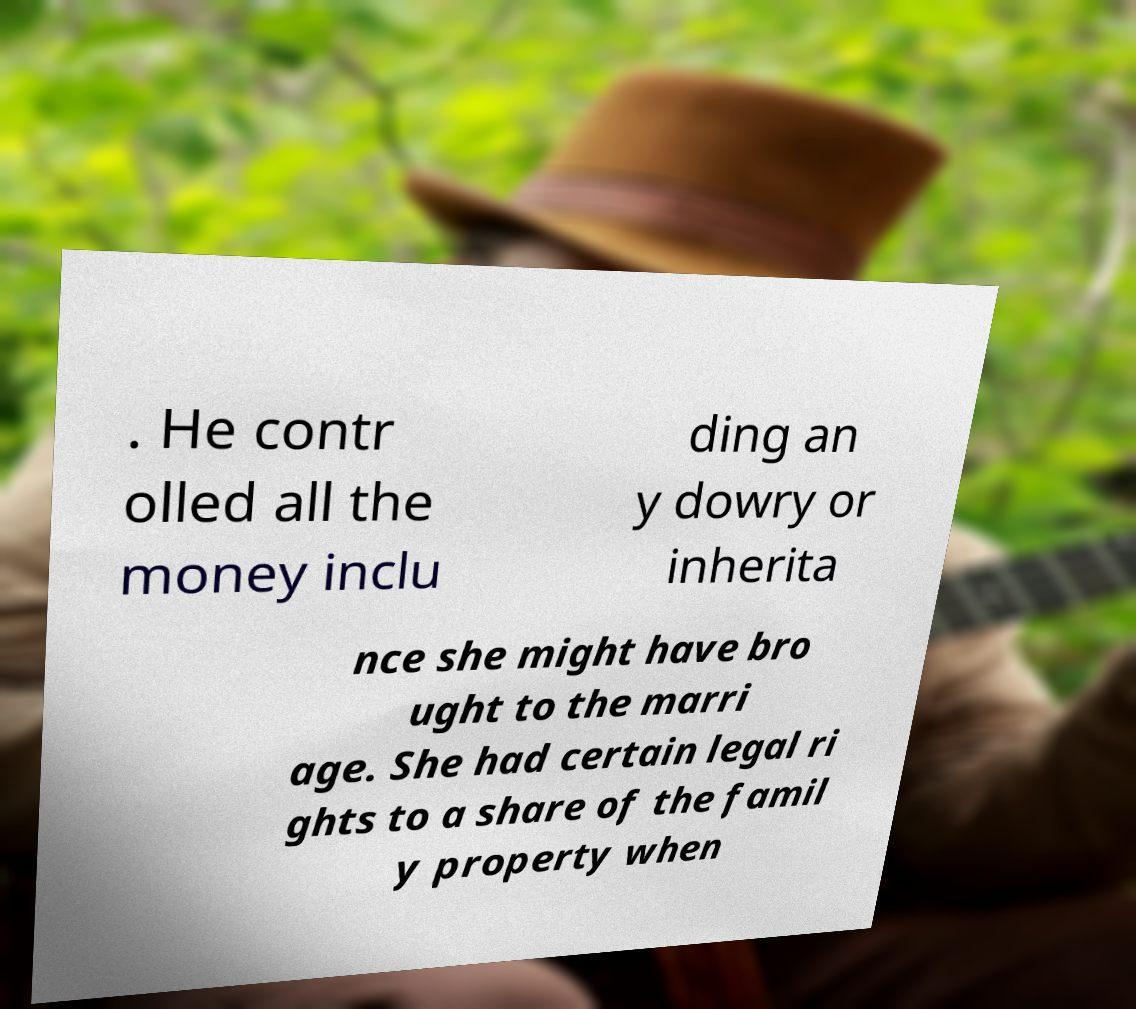Could you extract and type out the text from this image? . He contr olled all the money inclu ding an y dowry or inherita nce she might have bro ught to the marri age. She had certain legal ri ghts to a share of the famil y property when 